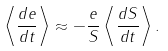Convert formula to latex. <formula><loc_0><loc_0><loc_500><loc_500>\left \langle \frac { d e } { d t } \right \rangle \approx - \frac { e } { S } \left \langle \frac { d S } { d t } \right \rangle .</formula> 